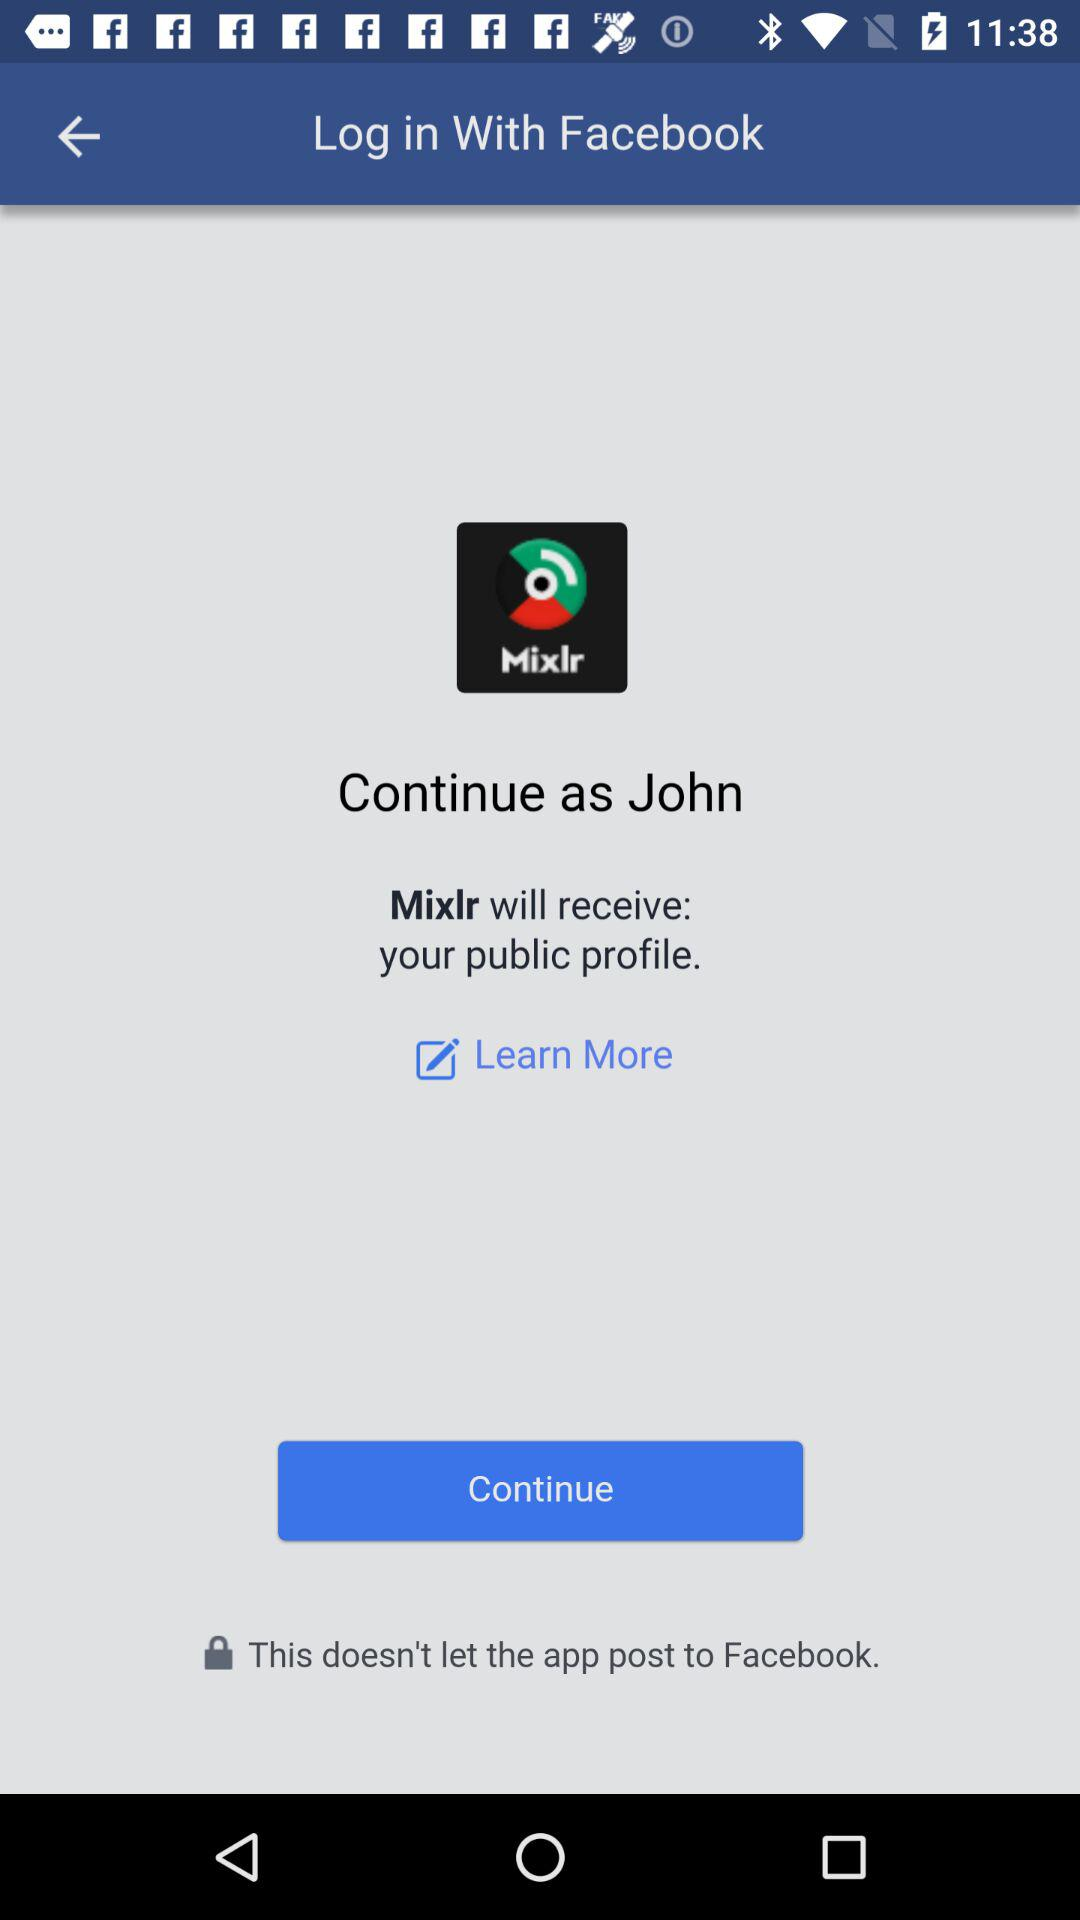Through what account can logging in be done? Logging in can be done through "Facebook" account. 